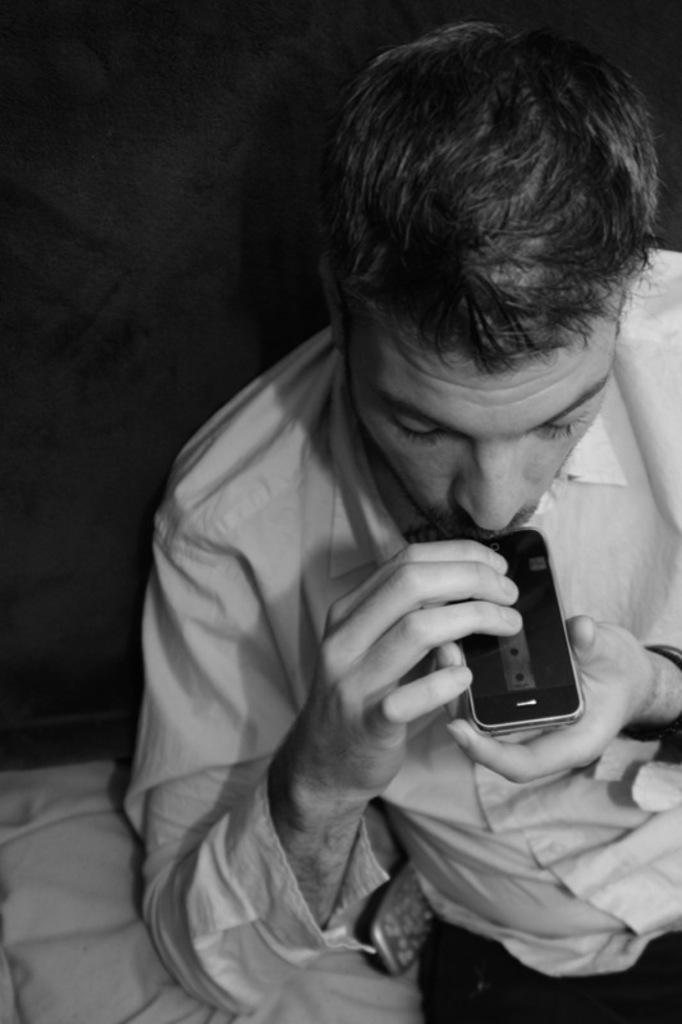What is the cat doing in the image? The cat is sitting on a windowsill and looking outside. What can be seen on the window in the image? There is a curtain on the window. What is the color of the cat in the image? The transcript does not mention the color of the cat. What is the purpose of the basket on the bicycle in the image? The transcript does not mention a bicycle in the image. How many pies are on the windowsill in the image? There is no mention of pies in the image. Is the cat a spy in the image? There is no indication in the image that the cat is a spy. 